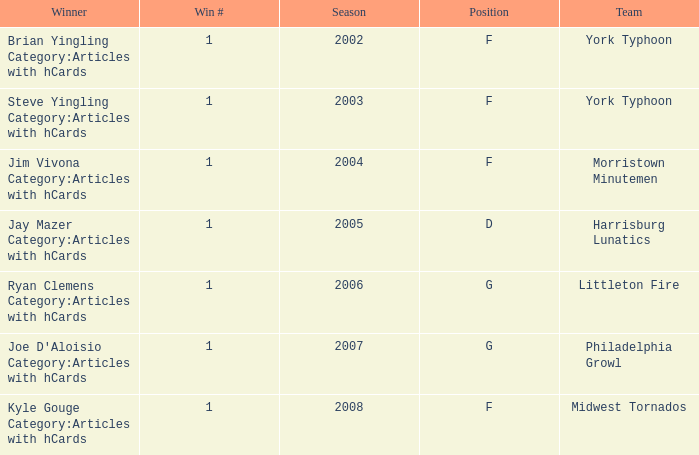Who was the winner in the 2008 season? Kyle Gouge Category:Articles with hCards. 